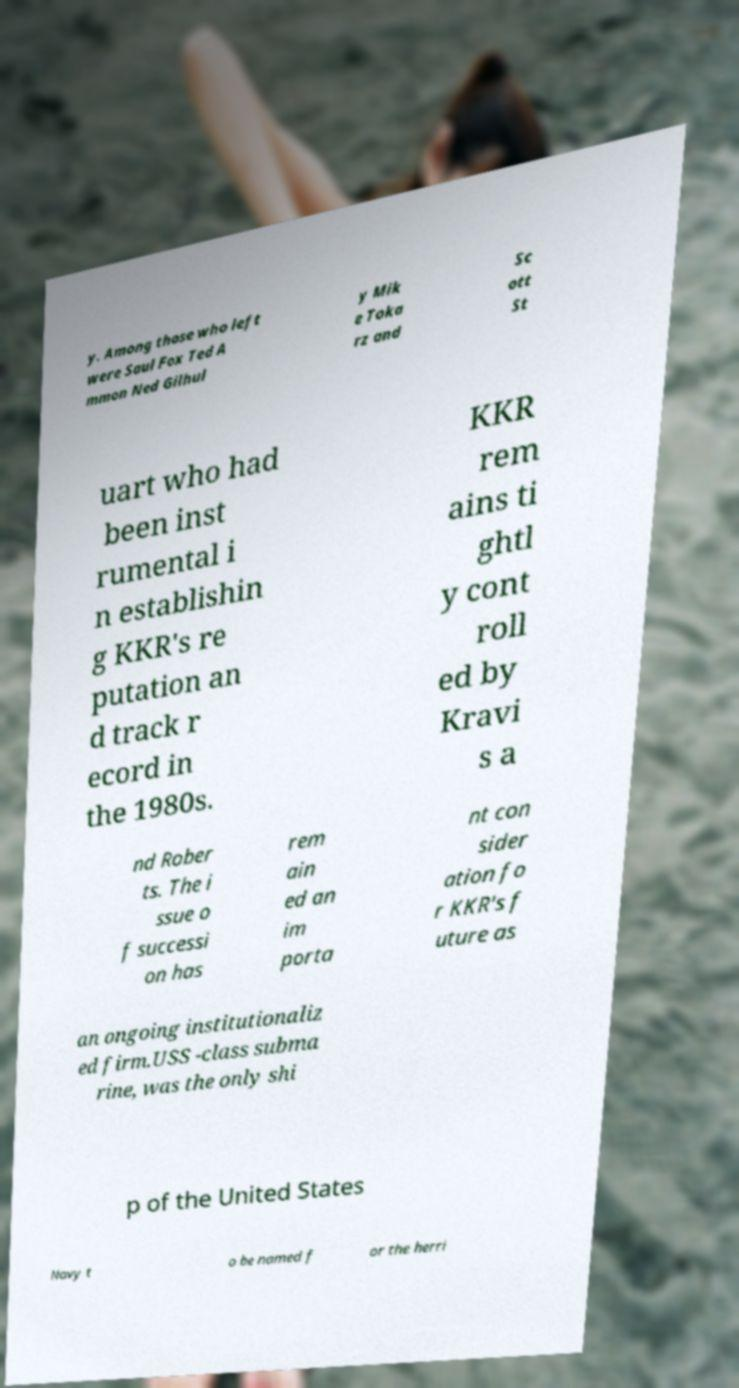Could you extract and type out the text from this image? y. Among those who left were Saul Fox Ted A mmon Ned Gilhul y Mik e Toka rz and Sc ott St uart who had been inst rumental i n establishin g KKR's re putation an d track r ecord in the 1980s. KKR rem ains ti ghtl y cont roll ed by Kravi s a nd Rober ts. The i ssue o f successi on has rem ain ed an im porta nt con sider ation fo r KKR's f uture as an ongoing institutionaliz ed firm.USS -class subma rine, was the only shi p of the United States Navy t o be named f or the herri 